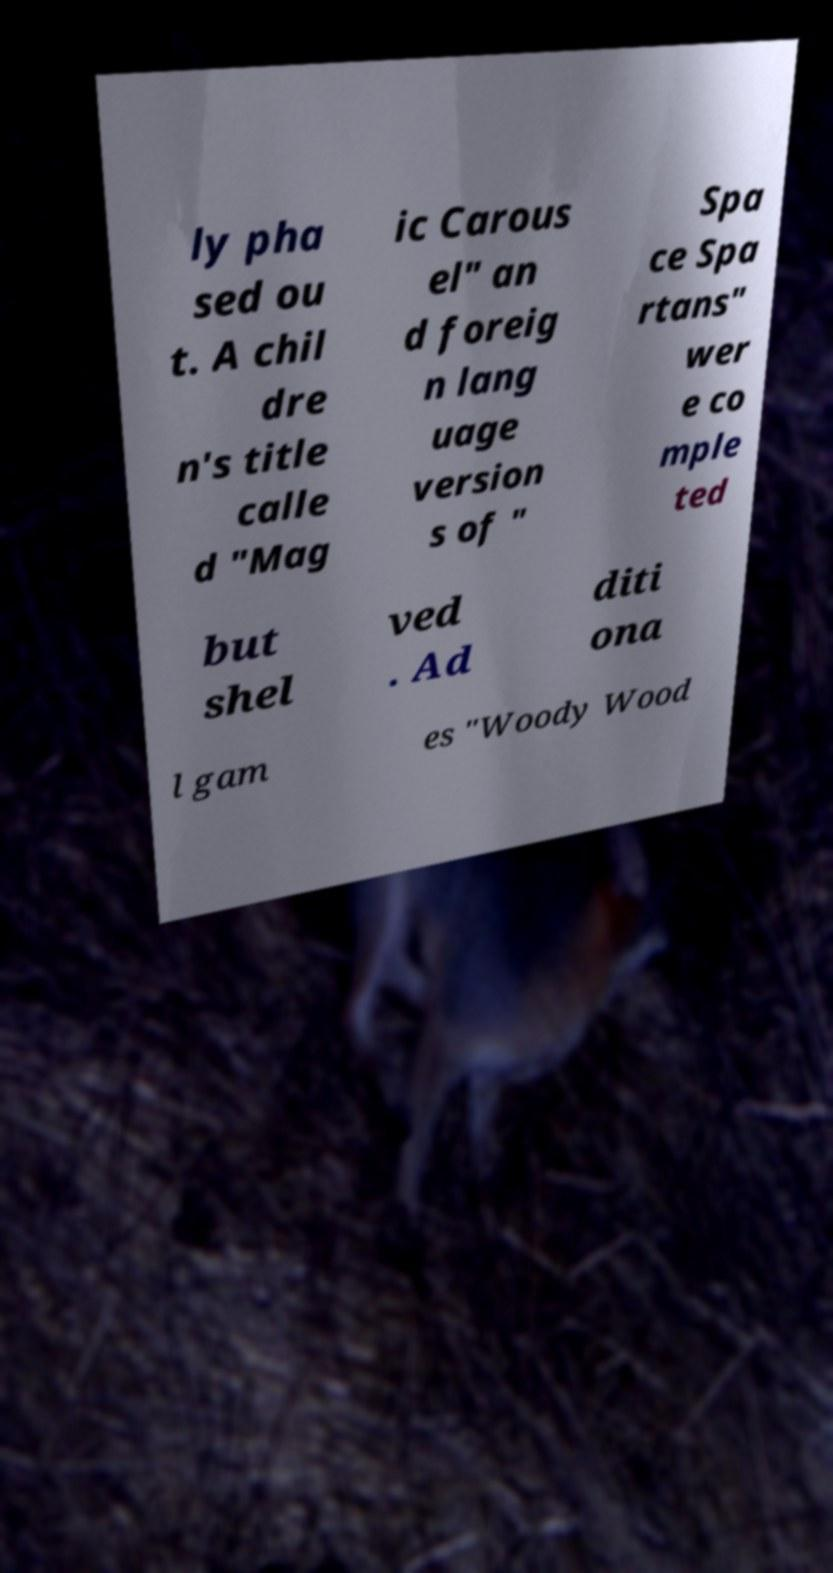There's text embedded in this image that I need extracted. Can you transcribe it verbatim? ly pha sed ou t. A chil dre n's title calle d "Mag ic Carous el" an d foreig n lang uage version s of " Spa ce Spa rtans" wer e co mple ted but shel ved . Ad diti ona l gam es "Woody Wood 